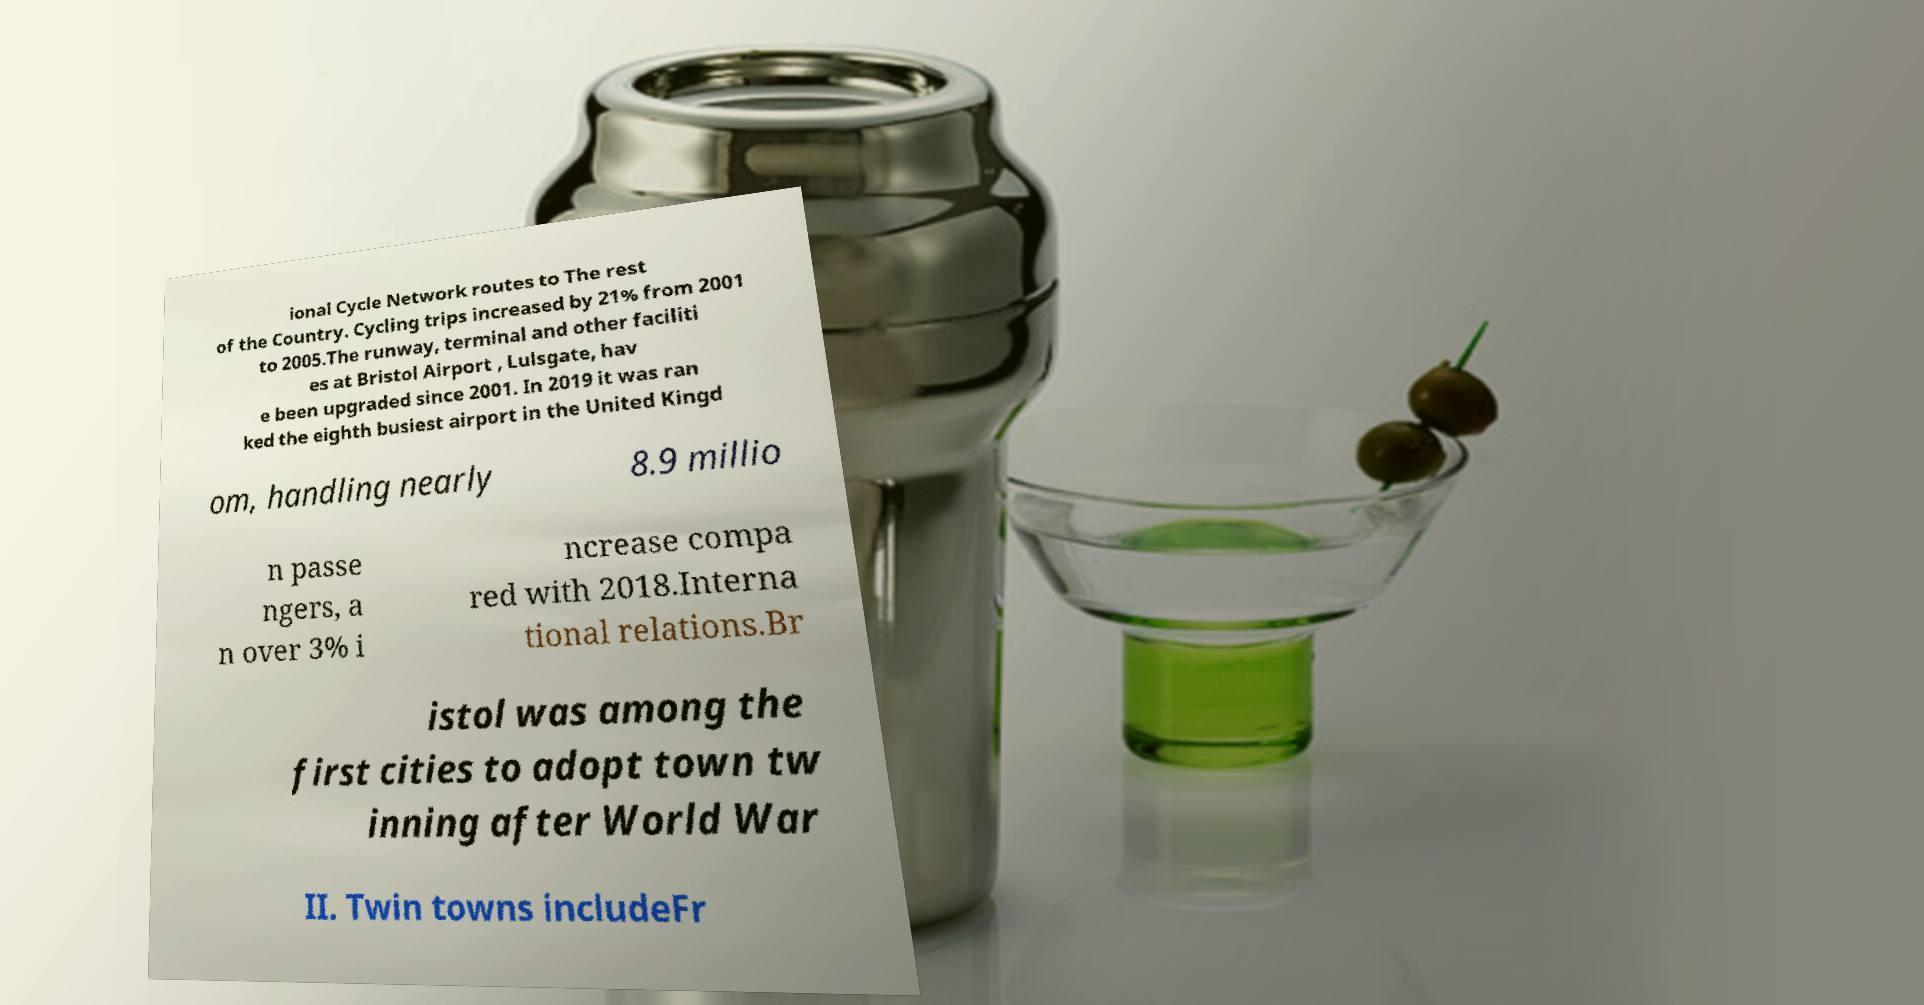Could you extract and type out the text from this image? ional Cycle Network routes to The rest of the Country. Cycling trips increased by 21% from 2001 to 2005.The runway, terminal and other faciliti es at Bristol Airport , Lulsgate, hav e been upgraded since 2001. In 2019 it was ran ked the eighth busiest airport in the United Kingd om, handling nearly 8.9 millio n passe ngers, a n over 3% i ncrease compa red with 2018.Interna tional relations.Br istol was among the first cities to adopt town tw inning after World War II. Twin towns includeFr 